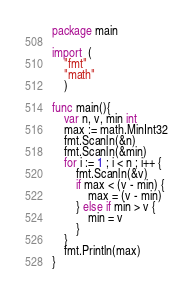<code> <loc_0><loc_0><loc_500><loc_500><_Go_>package main

import  (
    "fmt"
    "math"
    )

func main(){
    var n, v, min int
    max := math.MinInt32
    fmt.Scanln(&n)
    fmt.Scanln(&min)
    for i := 1 ; i < n ; i++ {
        fmt.Scanln(&v)
        if max < (v - min) {
            max = (v - min)
        } else if min > v {
            min = v
        }
    }
    fmt.Println(max)
}
</code> 